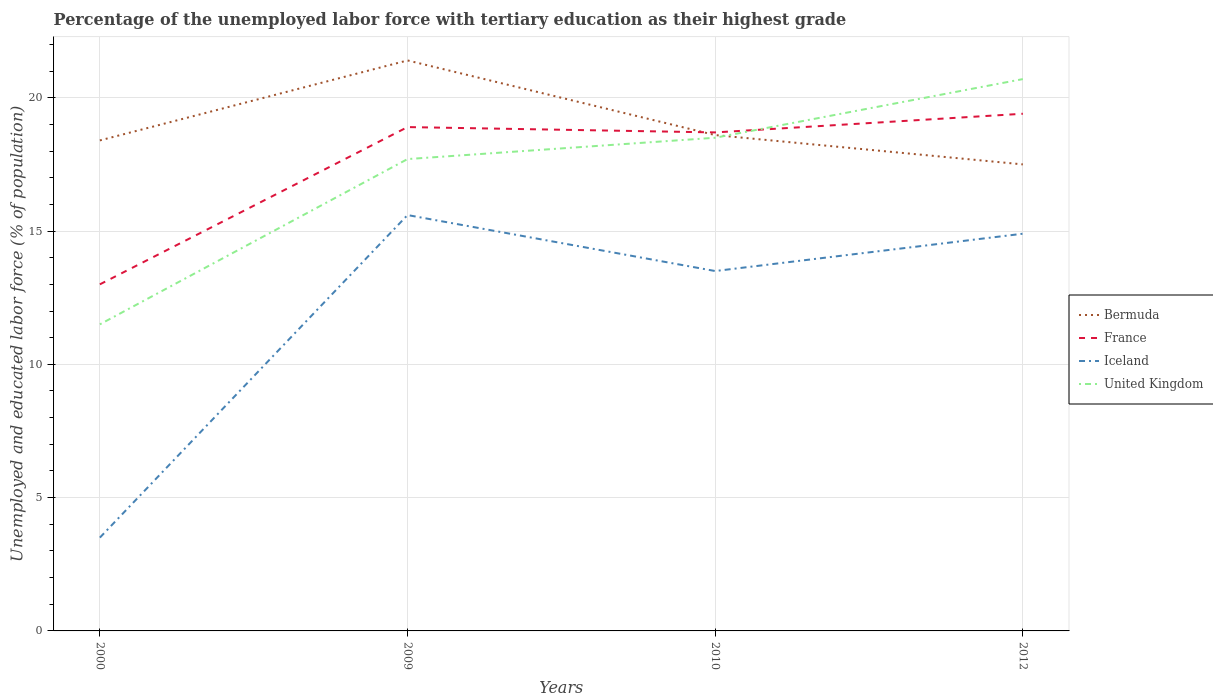How many different coloured lines are there?
Keep it short and to the point. 4. Is the number of lines equal to the number of legend labels?
Give a very brief answer. Yes. Across all years, what is the maximum percentage of the unemployed labor force with tertiary education in Iceland?
Keep it short and to the point. 3.5. What is the total percentage of the unemployed labor force with tertiary education in Bermuda in the graph?
Provide a short and direct response. 2.8. What is the difference between the highest and the second highest percentage of the unemployed labor force with tertiary education in United Kingdom?
Offer a very short reply. 9.2. What is the difference between the highest and the lowest percentage of the unemployed labor force with tertiary education in Iceland?
Your answer should be very brief. 3. Is the percentage of the unemployed labor force with tertiary education in United Kingdom strictly greater than the percentage of the unemployed labor force with tertiary education in Iceland over the years?
Your answer should be very brief. No. How many lines are there?
Your answer should be very brief. 4. How many years are there in the graph?
Your answer should be compact. 4. What is the difference between two consecutive major ticks on the Y-axis?
Offer a terse response. 5. Are the values on the major ticks of Y-axis written in scientific E-notation?
Your answer should be very brief. No. Does the graph contain any zero values?
Provide a short and direct response. No. Does the graph contain grids?
Your answer should be very brief. Yes. Where does the legend appear in the graph?
Keep it short and to the point. Center right. How are the legend labels stacked?
Provide a short and direct response. Vertical. What is the title of the graph?
Offer a very short reply. Percentage of the unemployed labor force with tertiary education as their highest grade. Does "Mauritius" appear as one of the legend labels in the graph?
Provide a short and direct response. No. What is the label or title of the Y-axis?
Your answer should be compact. Unemployed and educated labor force (% of population). What is the Unemployed and educated labor force (% of population) in Bermuda in 2000?
Make the answer very short. 18.4. What is the Unemployed and educated labor force (% of population) in France in 2000?
Offer a terse response. 13. What is the Unemployed and educated labor force (% of population) in Iceland in 2000?
Your answer should be very brief. 3.5. What is the Unemployed and educated labor force (% of population) of United Kingdom in 2000?
Provide a short and direct response. 11.5. What is the Unemployed and educated labor force (% of population) in Bermuda in 2009?
Give a very brief answer. 21.4. What is the Unemployed and educated labor force (% of population) of France in 2009?
Ensure brevity in your answer.  18.9. What is the Unemployed and educated labor force (% of population) of Iceland in 2009?
Make the answer very short. 15.6. What is the Unemployed and educated labor force (% of population) in United Kingdom in 2009?
Give a very brief answer. 17.7. What is the Unemployed and educated labor force (% of population) in Bermuda in 2010?
Keep it short and to the point. 18.6. What is the Unemployed and educated labor force (% of population) in France in 2010?
Keep it short and to the point. 18.7. What is the Unemployed and educated labor force (% of population) of Iceland in 2010?
Offer a very short reply. 13.5. What is the Unemployed and educated labor force (% of population) in United Kingdom in 2010?
Your response must be concise. 18.5. What is the Unemployed and educated labor force (% of population) in France in 2012?
Keep it short and to the point. 19.4. What is the Unemployed and educated labor force (% of population) of Iceland in 2012?
Your answer should be very brief. 14.9. What is the Unemployed and educated labor force (% of population) in United Kingdom in 2012?
Keep it short and to the point. 20.7. Across all years, what is the maximum Unemployed and educated labor force (% of population) in Bermuda?
Your answer should be compact. 21.4. Across all years, what is the maximum Unemployed and educated labor force (% of population) in France?
Give a very brief answer. 19.4. Across all years, what is the maximum Unemployed and educated labor force (% of population) in Iceland?
Provide a short and direct response. 15.6. Across all years, what is the maximum Unemployed and educated labor force (% of population) of United Kingdom?
Offer a terse response. 20.7. What is the total Unemployed and educated labor force (% of population) of Bermuda in the graph?
Your answer should be very brief. 75.9. What is the total Unemployed and educated labor force (% of population) in France in the graph?
Make the answer very short. 70. What is the total Unemployed and educated labor force (% of population) of Iceland in the graph?
Give a very brief answer. 47.5. What is the total Unemployed and educated labor force (% of population) of United Kingdom in the graph?
Provide a short and direct response. 68.4. What is the difference between the Unemployed and educated labor force (% of population) of Iceland in 2000 and that in 2009?
Your response must be concise. -12.1. What is the difference between the Unemployed and educated labor force (% of population) in Bermuda in 2000 and that in 2010?
Your answer should be very brief. -0.2. What is the difference between the Unemployed and educated labor force (% of population) of France in 2000 and that in 2010?
Offer a terse response. -5.7. What is the difference between the Unemployed and educated labor force (% of population) of United Kingdom in 2000 and that in 2010?
Your answer should be compact. -7. What is the difference between the Unemployed and educated labor force (% of population) of Bermuda in 2000 and that in 2012?
Provide a succinct answer. 0.9. What is the difference between the Unemployed and educated labor force (% of population) of Iceland in 2000 and that in 2012?
Provide a succinct answer. -11.4. What is the difference between the Unemployed and educated labor force (% of population) of United Kingdom in 2000 and that in 2012?
Provide a succinct answer. -9.2. What is the difference between the Unemployed and educated labor force (% of population) in Bermuda in 2009 and that in 2010?
Ensure brevity in your answer.  2.8. What is the difference between the Unemployed and educated labor force (% of population) in France in 2009 and that in 2010?
Make the answer very short. 0.2. What is the difference between the Unemployed and educated labor force (% of population) of France in 2009 and that in 2012?
Offer a terse response. -0.5. What is the difference between the Unemployed and educated labor force (% of population) of United Kingdom in 2009 and that in 2012?
Your answer should be very brief. -3. What is the difference between the Unemployed and educated labor force (% of population) in United Kingdom in 2010 and that in 2012?
Ensure brevity in your answer.  -2.2. What is the difference between the Unemployed and educated labor force (% of population) of Bermuda in 2000 and the Unemployed and educated labor force (% of population) of United Kingdom in 2009?
Provide a succinct answer. 0.7. What is the difference between the Unemployed and educated labor force (% of population) of France in 2000 and the Unemployed and educated labor force (% of population) of Iceland in 2009?
Your response must be concise. -2.6. What is the difference between the Unemployed and educated labor force (% of population) of France in 2000 and the Unemployed and educated labor force (% of population) of United Kingdom in 2009?
Provide a short and direct response. -4.7. What is the difference between the Unemployed and educated labor force (% of population) of Bermuda in 2000 and the Unemployed and educated labor force (% of population) of Iceland in 2010?
Your answer should be very brief. 4.9. What is the difference between the Unemployed and educated labor force (% of population) of Bermuda in 2000 and the Unemployed and educated labor force (% of population) of United Kingdom in 2010?
Offer a very short reply. -0.1. What is the difference between the Unemployed and educated labor force (% of population) of France in 2000 and the Unemployed and educated labor force (% of population) of Iceland in 2010?
Your answer should be compact. -0.5. What is the difference between the Unemployed and educated labor force (% of population) of Bermuda in 2000 and the Unemployed and educated labor force (% of population) of France in 2012?
Provide a succinct answer. -1. What is the difference between the Unemployed and educated labor force (% of population) of France in 2000 and the Unemployed and educated labor force (% of population) of United Kingdom in 2012?
Your answer should be very brief. -7.7. What is the difference between the Unemployed and educated labor force (% of population) of Iceland in 2000 and the Unemployed and educated labor force (% of population) of United Kingdom in 2012?
Your response must be concise. -17.2. What is the difference between the Unemployed and educated labor force (% of population) in Bermuda in 2009 and the Unemployed and educated labor force (% of population) in Iceland in 2010?
Offer a terse response. 7.9. What is the difference between the Unemployed and educated labor force (% of population) of France in 2009 and the Unemployed and educated labor force (% of population) of United Kingdom in 2010?
Make the answer very short. 0.4. What is the difference between the Unemployed and educated labor force (% of population) of Bermuda in 2009 and the Unemployed and educated labor force (% of population) of France in 2012?
Offer a terse response. 2. What is the difference between the Unemployed and educated labor force (% of population) in France in 2009 and the Unemployed and educated labor force (% of population) in Iceland in 2012?
Your answer should be compact. 4. What is the difference between the Unemployed and educated labor force (% of population) in Iceland in 2009 and the Unemployed and educated labor force (% of population) in United Kingdom in 2012?
Your response must be concise. -5.1. What is the difference between the Unemployed and educated labor force (% of population) in Bermuda in 2010 and the Unemployed and educated labor force (% of population) in United Kingdom in 2012?
Ensure brevity in your answer.  -2.1. What is the difference between the Unemployed and educated labor force (% of population) of France in 2010 and the Unemployed and educated labor force (% of population) of Iceland in 2012?
Provide a succinct answer. 3.8. What is the average Unemployed and educated labor force (% of population) in Bermuda per year?
Offer a very short reply. 18.98. What is the average Unemployed and educated labor force (% of population) of Iceland per year?
Offer a terse response. 11.88. What is the average Unemployed and educated labor force (% of population) of United Kingdom per year?
Offer a very short reply. 17.1. In the year 2000, what is the difference between the Unemployed and educated labor force (% of population) of France and Unemployed and educated labor force (% of population) of Iceland?
Offer a very short reply. 9.5. In the year 2000, what is the difference between the Unemployed and educated labor force (% of population) in France and Unemployed and educated labor force (% of population) in United Kingdom?
Offer a very short reply. 1.5. In the year 2000, what is the difference between the Unemployed and educated labor force (% of population) of Iceland and Unemployed and educated labor force (% of population) of United Kingdom?
Offer a terse response. -8. In the year 2009, what is the difference between the Unemployed and educated labor force (% of population) in Bermuda and Unemployed and educated labor force (% of population) in Iceland?
Make the answer very short. 5.8. In the year 2009, what is the difference between the Unemployed and educated labor force (% of population) of Bermuda and Unemployed and educated labor force (% of population) of United Kingdom?
Ensure brevity in your answer.  3.7. In the year 2009, what is the difference between the Unemployed and educated labor force (% of population) in France and Unemployed and educated labor force (% of population) in Iceland?
Ensure brevity in your answer.  3.3. In the year 2009, what is the difference between the Unemployed and educated labor force (% of population) in Iceland and Unemployed and educated labor force (% of population) in United Kingdom?
Provide a short and direct response. -2.1. In the year 2010, what is the difference between the Unemployed and educated labor force (% of population) of France and Unemployed and educated labor force (% of population) of Iceland?
Your answer should be compact. 5.2. In the year 2010, what is the difference between the Unemployed and educated labor force (% of population) in France and Unemployed and educated labor force (% of population) in United Kingdom?
Provide a succinct answer. 0.2. In the year 2010, what is the difference between the Unemployed and educated labor force (% of population) of Iceland and Unemployed and educated labor force (% of population) of United Kingdom?
Your response must be concise. -5. In the year 2012, what is the difference between the Unemployed and educated labor force (% of population) in Bermuda and Unemployed and educated labor force (% of population) in United Kingdom?
Provide a succinct answer. -3.2. What is the ratio of the Unemployed and educated labor force (% of population) of Bermuda in 2000 to that in 2009?
Offer a terse response. 0.86. What is the ratio of the Unemployed and educated labor force (% of population) of France in 2000 to that in 2009?
Ensure brevity in your answer.  0.69. What is the ratio of the Unemployed and educated labor force (% of population) of Iceland in 2000 to that in 2009?
Keep it short and to the point. 0.22. What is the ratio of the Unemployed and educated labor force (% of population) in United Kingdom in 2000 to that in 2009?
Your response must be concise. 0.65. What is the ratio of the Unemployed and educated labor force (% of population) of France in 2000 to that in 2010?
Your answer should be compact. 0.7. What is the ratio of the Unemployed and educated labor force (% of population) of Iceland in 2000 to that in 2010?
Make the answer very short. 0.26. What is the ratio of the Unemployed and educated labor force (% of population) in United Kingdom in 2000 to that in 2010?
Your answer should be very brief. 0.62. What is the ratio of the Unemployed and educated labor force (% of population) of Bermuda in 2000 to that in 2012?
Keep it short and to the point. 1.05. What is the ratio of the Unemployed and educated labor force (% of population) in France in 2000 to that in 2012?
Keep it short and to the point. 0.67. What is the ratio of the Unemployed and educated labor force (% of population) in Iceland in 2000 to that in 2012?
Offer a terse response. 0.23. What is the ratio of the Unemployed and educated labor force (% of population) of United Kingdom in 2000 to that in 2012?
Keep it short and to the point. 0.56. What is the ratio of the Unemployed and educated labor force (% of population) of Bermuda in 2009 to that in 2010?
Keep it short and to the point. 1.15. What is the ratio of the Unemployed and educated labor force (% of population) in France in 2009 to that in 2010?
Give a very brief answer. 1.01. What is the ratio of the Unemployed and educated labor force (% of population) of Iceland in 2009 to that in 2010?
Your response must be concise. 1.16. What is the ratio of the Unemployed and educated labor force (% of population) in United Kingdom in 2009 to that in 2010?
Your answer should be compact. 0.96. What is the ratio of the Unemployed and educated labor force (% of population) of Bermuda in 2009 to that in 2012?
Your answer should be compact. 1.22. What is the ratio of the Unemployed and educated labor force (% of population) of France in 2009 to that in 2012?
Offer a very short reply. 0.97. What is the ratio of the Unemployed and educated labor force (% of population) in Iceland in 2009 to that in 2012?
Make the answer very short. 1.05. What is the ratio of the Unemployed and educated labor force (% of population) of United Kingdom in 2009 to that in 2012?
Give a very brief answer. 0.86. What is the ratio of the Unemployed and educated labor force (% of population) in Bermuda in 2010 to that in 2012?
Your answer should be very brief. 1.06. What is the ratio of the Unemployed and educated labor force (% of population) in France in 2010 to that in 2012?
Keep it short and to the point. 0.96. What is the ratio of the Unemployed and educated labor force (% of population) in Iceland in 2010 to that in 2012?
Make the answer very short. 0.91. What is the ratio of the Unemployed and educated labor force (% of population) of United Kingdom in 2010 to that in 2012?
Give a very brief answer. 0.89. What is the difference between the highest and the second highest Unemployed and educated labor force (% of population) of Bermuda?
Provide a succinct answer. 2.8. What is the difference between the highest and the lowest Unemployed and educated labor force (% of population) of Bermuda?
Offer a very short reply. 3.9. What is the difference between the highest and the lowest Unemployed and educated labor force (% of population) of France?
Offer a very short reply. 6.4. What is the difference between the highest and the lowest Unemployed and educated labor force (% of population) in Iceland?
Give a very brief answer. 12.1. 